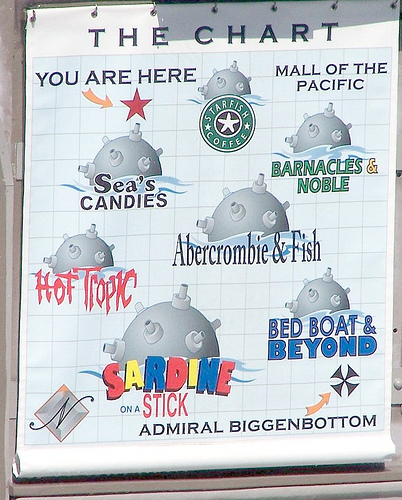<image>
Is there a pacific in front of the fish? No. The pacific is not in front of the fish. The spatial positioning shows a different relationship between these objects. 